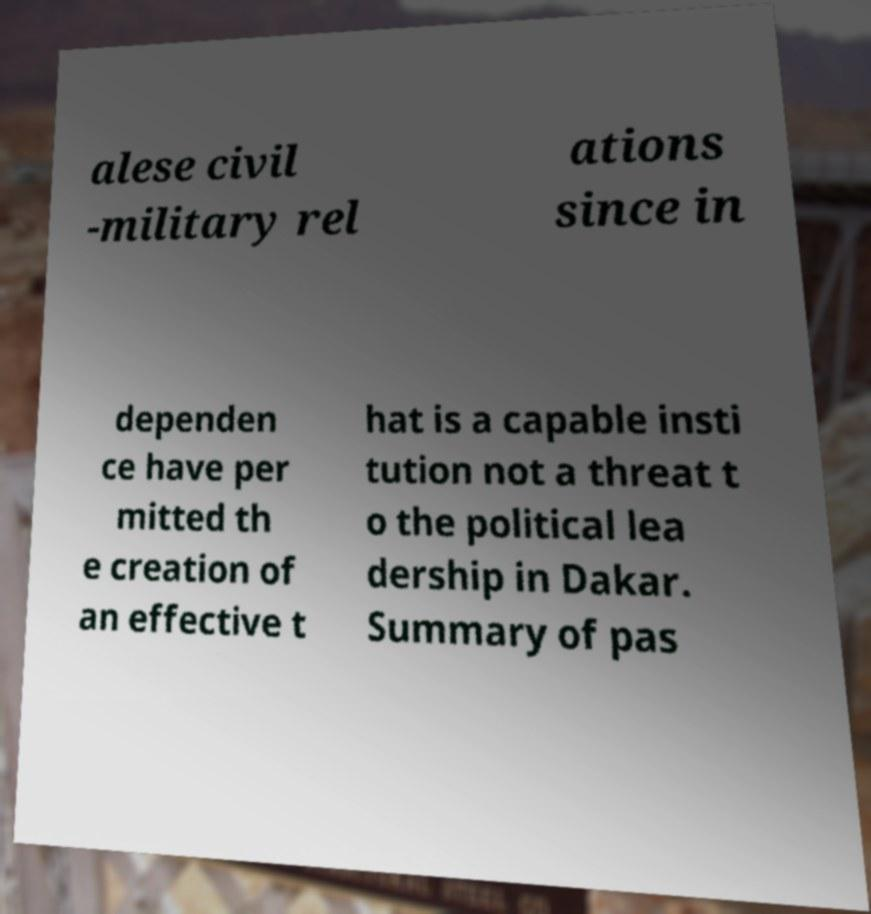I need the written content from this picture converted into text. Can you do that? alese civil -military rel ations since in dependen ce have per mitted th e creation of an effective t hat is a capable insti tution not a threat t o the political lea dership in Dakar. Summary of pas 